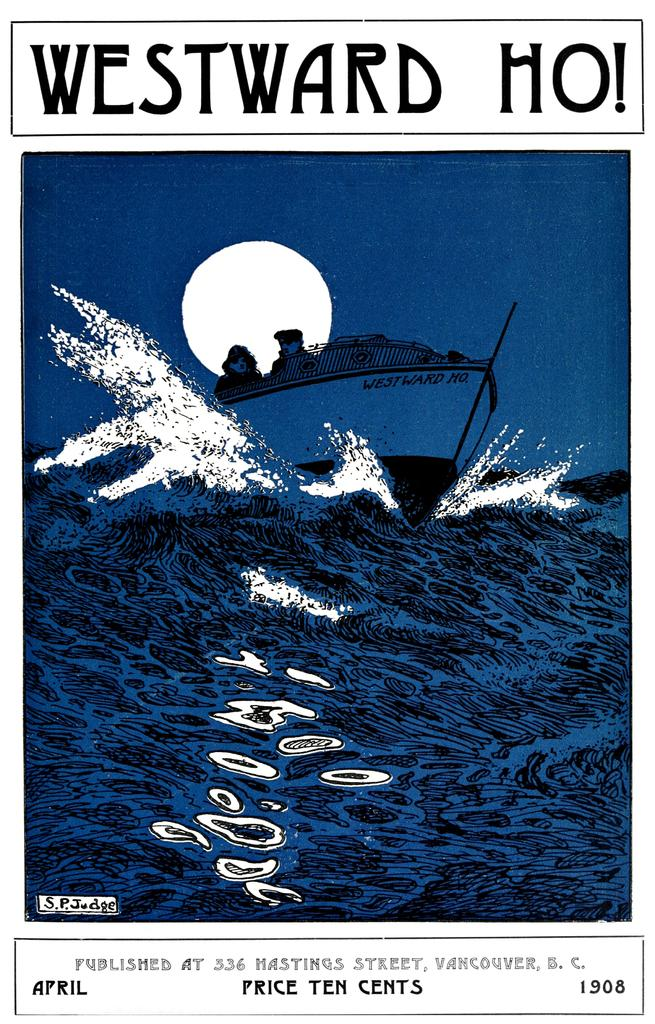What is featured on the poster in the image? There is a poster in the image, and it contains an image of water and a boat. Can you describe the image of water on the poster? The image of water on the poster is not described in detail, but it is mentioned as a part of the poster's content. What else is depicted on the poster besides the image of water? The poster also contains an image of a boat. How many snakes are slithering on the poster in the image? There are no snakes present on the poster in the image; it features images of water and a boat. What type of slip is shown on the poster? There is no slip depicted on the poster; it only contains images of water and a boat. 